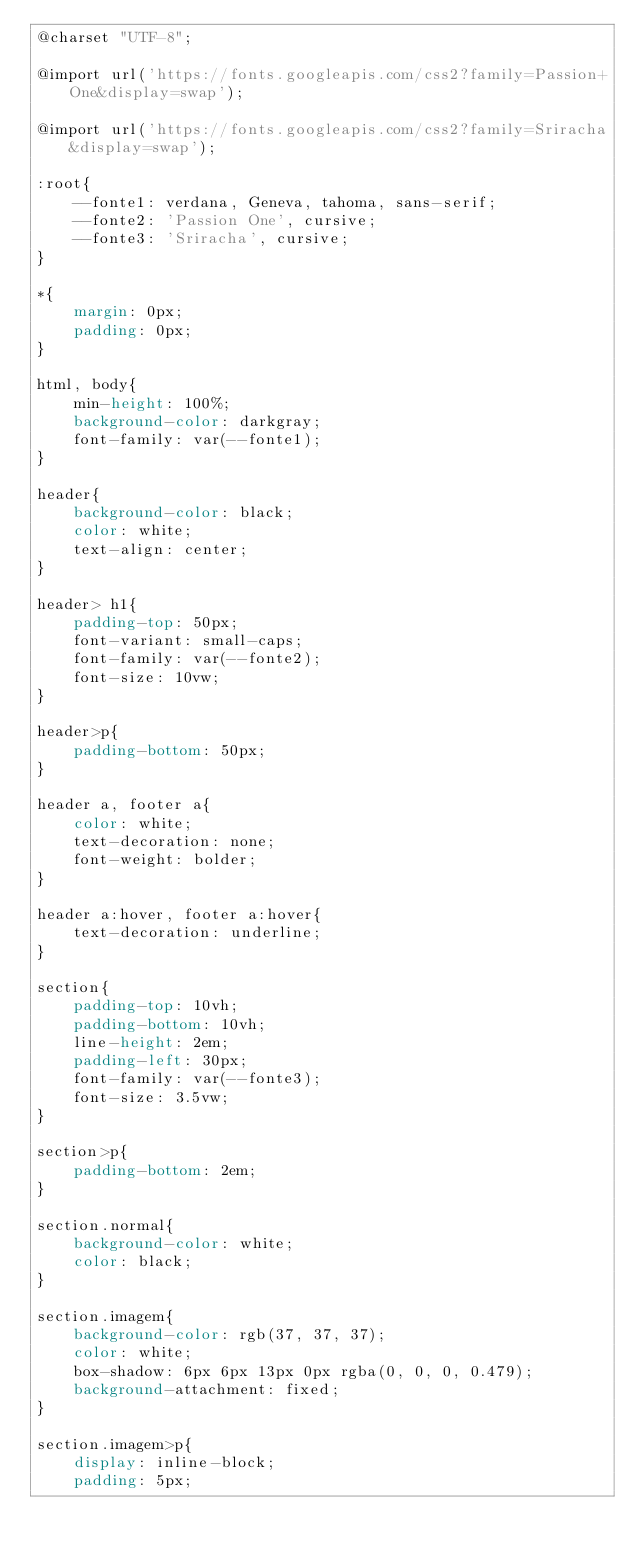<code> <loc_0><loc_0><loc_500><loc_500><_CSS_>@charset "UTF-8";

@import url('https://fonts.googleapis.com/css2?family=Passion+One&display=swap');

@import url('https://fonts.googleapis.com/css2?family=Sriracha&display=swap');

:root{
    --fonte1: verdana, Geneva, tahoma, sans-serif;
    --fonte2: 'Passion One', cursive;
    --fonte3: 'Sriracha', cursive;
}

*{
    margin: 0px;
    padding: 0px;
}

html, body{
    min-height: 100%;
    background-color: darkgray;
    font-family: var(--fonte1);
}

header{
    background-color: black;
    color: white;
    text-align: center;
}

header> h1{
    padding-top: 50px;
    font-variant: small-caps;
    font-family: var(--fonte2);
    font-size: 10vw;
}

header>p{
    padding-bottom: 50px;
}

header a, footer a{
    color: white;
    text-decoration: none;
    font-weight: bolder;
}

header a:hover, footer a:hover{
    text-decoration: underline;
}

section{
    padding-top: 10vh;
    padding-bottom: 10vh;
    line-height: 2em;
    padding-left: 30px;
    font-family: var(--fonte3);
    font-size: 3.5vw;
}

section>p{
    padding-bottom: 2em;
}

section.normal{
    background-color: white;
    color: black;
}

section.imagem{
    background-color: rgb(37, 37, 37);
    color: white;
    box-shadow: 6px 6px 13px 0px rgba(0, 0, 0, 0.479);
    background-attachment: fixed;
}

section.imagem>p{
    display: inline-block;
    padding: 5px;</code> 